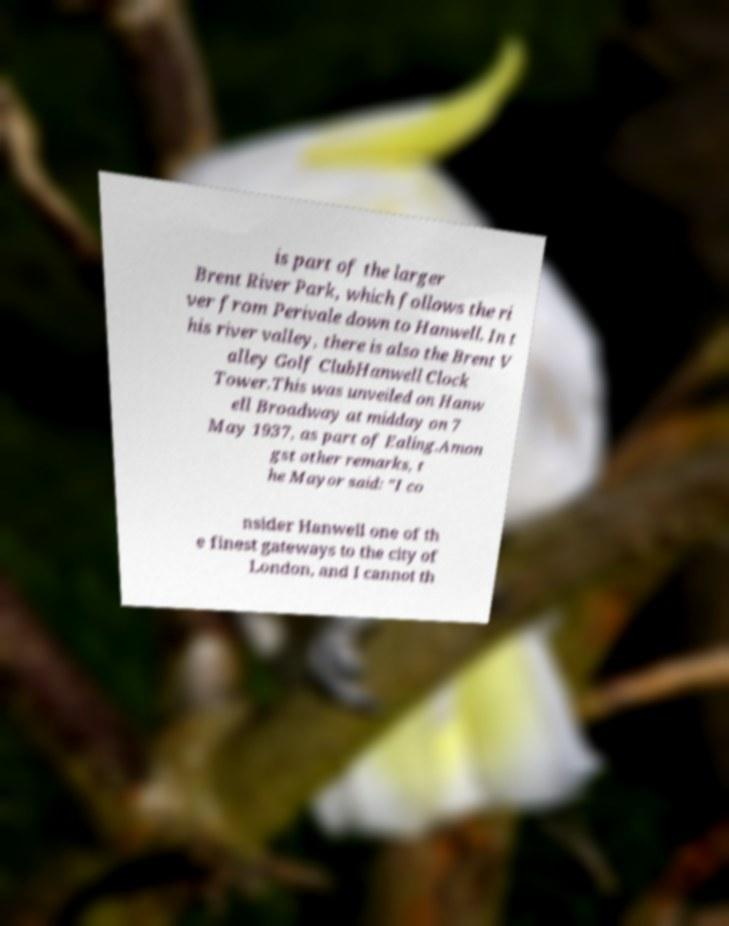Can you accurately transcribe the text from the provided image for me? is part of the larger Brent River Park, which follows the ri ver from Perivale down to Hanwell. In t his river valley, there is also the Brent V alley Golf ClubHanwell Clock Tower.This was unveiled on Hanw ell Broadway at midday on 7 May 1937, as part of Ealing.Amon gst other remarks, t he Mayor said: "I co nsider Hanwell one of th e finest gateways to the city of London, and I cannot th 